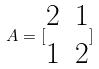<formula> <loc_0><loc_0><loc_500><loc_500>A = [ \begin{matrix} 2 & 1 \\ 1 & 2 \end{matrix} ]</formula> 